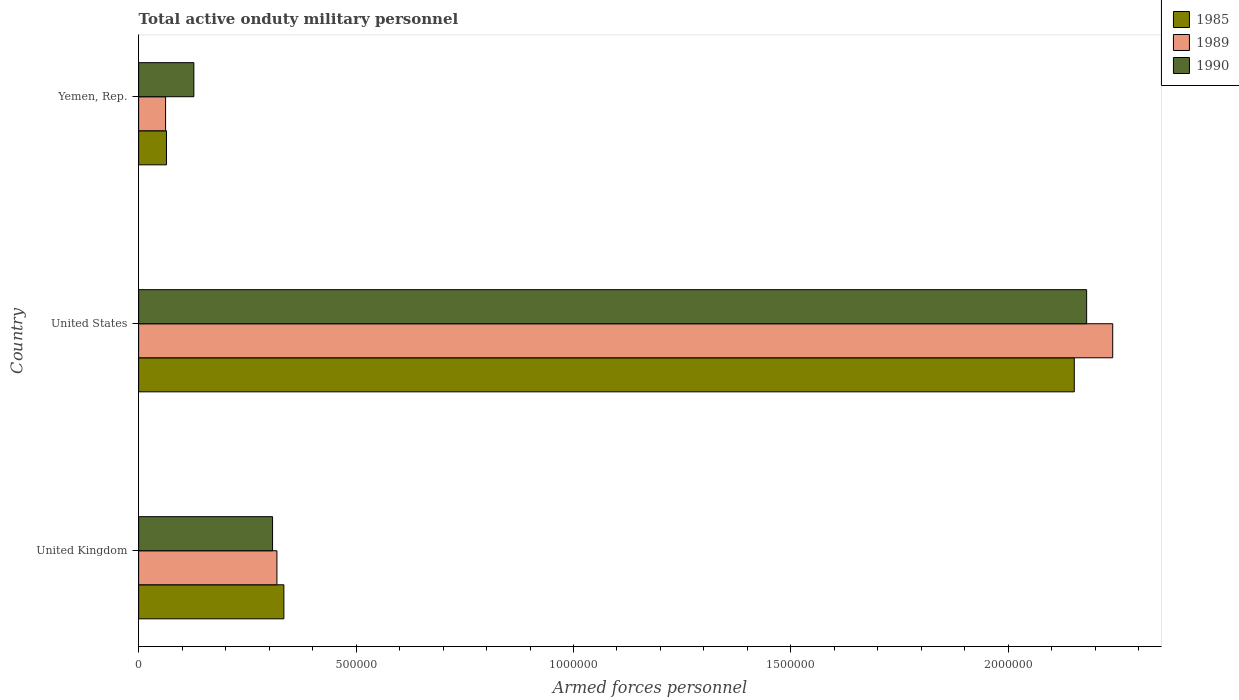Are the number of bars per tick equal to the number of legend labels?
Give a very brief answer. Yes. How many bars are there on the 3rd tick from the top?
Make the answer very short. 3. What is the number of armed forces personnel in 1985 in United Kingdom?
Give a very brief answer. 3.34e+05. Across all countries, what is the maximum number of armed forces personnel in 1985?
Provide a succinct answer. 2.15e+06. Across all countries, what is the minimum number of armed forces personnel in 1985?
Make the answer very short. 6.41e+04. In which country was the number of armed forces personnel in 1985 minimum?
Your response must be concise. Yemen, Rep. What is the total number of armed forces personnel in 1990 in the graph?
Your response must be concise. 2.62e+06. What is the difference between the number of armed forces personnel in 1985 in United Kingdom and that in Yemen, Rep.?
Provide a short and direct response. 2.70e+05. What is the difference between the number of armed forces personnel in 1989 in Yemen, Rep. and the number of armed forces personnel in 1990 in United States?
Offer a terse response. -2.12e+06. What is the average number of armed forces personnel in 1985 per country?
Provide a short and direct response. 8.50e+05. What is the difference between the number of armed forces personnel in 1990 and number of armed forces personnel in 1985 in United Kingdom?
Keep it short and to the point. -2.60e+04. In how many countries, is the number of armed forces personnel in 1990 greater than 1700000 ?
Provide a succinct answer. 1. What is the ratio of the number of armed forces personnel in 1985 in United States to that in Yemen, Rep.?
Offer a very short reply. 33.57. Is the difference between the number of armed forces personnel in 1990 in United Kingdom and Yemen, Rep. greater than the difference between the number of armed forces personnel in 1985 in United Kingdom and Yemen, Rep.?
Your answer should be very brief. No. What is the difference between the highest and the second highest number of armed forces personnel in 1989?
Make the answer very short. 1.92e+06. What is the difference between the highest and the lowest number of armed forces personnel in 1990?
Provide a succinct answer. 2.05e+06. In how many countries, is the number of armed forces personnel in 1990 greater than the average number of armed forces personnel in 1990 taken over all countries?
Provide a short and direct response. 1. What does the 2nd bar from the bottom in United Kingdom represents?
Offer a terse response. 1989. Is it the case that in every country, the sum of the number of armed forces personnel in 1985 and number of armed forces personnel in 1990 is greater than the number of armed forces personnel in 1989?
Offer a very short reply. Yes. Are all the bars in the graph horizontal?
Your response must be concise. Yes. How many countries are there in the graph?
Keep it short and to the point. 3. What is the difference between two consecutive major ticks on the X-axis?
Offer a very short reply. 5.00e+05. Are the values on the major ticks of X-axis written in scientific E-notation?
Offer a terse response. No. Where does the legend appear in the graph?
Ensure brevity in your answer.  Top right. What is the title of the graph?
Make the answer very short. Total active onduty military personnel. What is the label or title of the X-axis?
Provide a short and direct response. Armed forces personnel. What is the Armed forces personnel of 1985 in United Kingdom?
Provide a succinct answer. 3.34e+05. What is the Armed forces personnel of 1989 in United Kingdom?
Make the answer very short. 3.18e+05. What is the Armed forces personnel in 1990 in United Kingdom?
Provide a succinct answer. 3.08e+05. What is the Armed forces personnel of 1985 in United States?
Give a very brief answer. 2.15e+06. What is the Armed forces personnel of 1989 in United States?
Your response must be concise. 2.24e+06. What is the Armed forces personnel of 1990 in United States?
Provide a short and direct response. 2.18e+06. What is the Armed forces personnel in 1985 in Yemen, Rep.?
Provide a short and direct response. 6.41e+04. What is the Armed forces personnel of 1989 in Yemen, Rep.?
Your answer should be very brief. 6.20e+04. What is the Armed forces personnel of 1990 in Yemen, Rep.?
Provide a short and direct response. 1.27e+05. Across all countries, what is the maximum Armed forces personnel of 1985?
Your answer should be compact. 2.15e+06. Across all countries, what is the maximum Armed forces personnel in 1989?
Offer a terse response. 2.24e+06. Across all countries, what is the maximum Armed forces personnel in 1990?
Your response must be concise. 2.18e+06. Across all countries, what is the minimum Armed forces personnel of 1985?
Ensure brevity in your answer.  6.41e+04. Across all countries, what is the minimum Armed forces personnel in 1989?
Make the answer very short. 6.20e+04. Across all countries, what is the minimum Armed forces personnel in 1990?
Ensure brevity in your answer.  1.27e+05. What is the total Armed forces personnel in 1985 in the graph?
Your response must be concise. 2.55e+06. What is the total Armed forces personnel in 1989 in the graph?
Make the answer very short. 2.62e+06. What is the total Armed forces personnel in 1990 in the graph?
Ensure brevity in your answer.  2.62e+06. What is the difference between the Armed forces personnel of 1985 in United Kingdom and that in United States?
Your answer should be compact. -1.82e+06. What is the difference between the Armed forces personnel of 1989 in United Kingdom and that in United States?
Make the answer very short. -1.92e+06. What is the difference between the Armed forces personnel in 1990 in United Kingdom and that in United States?
Provide a succinct answer. -1.87e+06. What is the difference between the Armed forces personnel in 1985 in United Kingdom and that in Yemen, Rep.?
Your answer should be very brief. 2.70e+05. What is the difference between the Armed forces personnel of 1989 in United Kingdom and that in Yemen, Rep.?
Your answer should be compact. 2.56e+05. What is the difference between the Armed forces personnel of 1990 in United Kingdom and that in Yemen, Rep.?
Provide a succinct answer. 1.81e+05. What is the difference between the Armed forces personnel of 1985 in United States and that in Yemen, Rep.?
Provide a short and direct response. 2.09e+06. What is the difference between the Armed forces personnel of 1989 in United States and that in Yemen, Rep.?
Your response must be concise. 2.18e+06. What is the difference between the Armed forces personnel in 1990 in United States and that in Yemen, Rep.?
Offer a very short reply. 2.05e+06. What is the difference between the Armed forces personnel in 1985 in United Kingdom and the Armed forces personnel in 1989 in United States?
Your response must be concise. -1.91e+06. What is the difference between the Armed forces personnel of 1985 in United Kingdom and the Armed forces personnel of 1990 in United States?
Your answer should be very brief. -1.85e+06. What is the difference between the Armed forces personnel of 1989 in United Kingdom and the Armed forces personnel of 1990 in United States?
Ensure brevity in your answer.  -1.86e+06. What is the difference between the Armed forces personnel of 1985 in United Kingdom and the Armed forces personnel of 1989 in Yemen, Rep.?
Your answer should be compact. 2.72e+05. What is the difference between the Armed forces personnel in 1985 in United Kingdom and the Armed forces personnel in 1990 in Yemen, Rep.?
Ensure brevity in your answer.  2.07e+05. What is the difference between the Armed forces personnel in 1989 in United Kingdom and the Armed forces personnel in 1990 in Yemen, Rep.?
Provide a short and direct response. 1.91e+05. What is the difference between the Armed forces personnel of 1985 in United States and the Armed forces personnel of 1989 in Yemen, Rep.?
Your answer should be compact. 2.09e+06. What is the difference between the Armed forces personnel in 1985 in United States and the Armed forces personnel in 1990 in Yemen, Rep.?
Keep it short and to the point. 2.02e+06. What is the difference between the Armed forces personnel of 1989 in United States and the Armed forces personnel of 1990 in Yemen, Rep.?
Keep it short and to the point. 2.11e+06. What is the average Armed forces personnel of 1985 per country?
Make the answer very short. 8.50e+05. What is the average Armed forces personnel of 1989 per country?
Provide a succinct answer. 8.73e+05. What is the average Armed forces personnel in 1990 per country?
Offer a terse response. 8.72e+05. What is the difference between the Armed forces personnel of 1985 and Armed forces personnel of 1989 in United Kingdom?
Your response must be concise. 1.60e+04. What is the difference between the Armed forces personnel of 1985 and Armed forces personnel of 1990 in United Kingdom?
Provide a short and direct response. 2.60e+04. What is the difference between the Armed forces personnel in 1989 and Armed forces personnel in 1990 in United Kingdom?
Your answer should be compact. 10000. What is the difference between the Armed forces personnel in 1985 and Armed forces personnel in 1989 in United States?
Offer a very short reply. -8.84e+04. What is the difference between the Armed forces personnel of 1985 and Armed forces personnel of 1990 in United States?
Your answer should be very brief. -2.84e+04. What is the difference between the Armed forces personnel in 1989 and Armed forces personnel in 1990 in United States?
Offer a terse response. 6.00e+04. What is the difference between the Armed forces personnel of 1985 and Armed forces personnel of 1989 in Yemen, Rep.?
Keep it short and to the point. 2100. What is the difference between the Armed forces personnel of 1985 and Armed forces personnel of 1990 in Yemen, Rep.?
Ensure brevity in your answer.  -6.29e+04. What is the difference between the Armed forces personnel in 1989 and Armed forces personnel in 1990 in Yemen, Rep.?
Your answer should be very brief. -6.50e+04. What is the ratio of the Armed forces personnel in 1985 in United Kingdom to that in United States?
Provide a short and direct response. 0.16. What is the ratio of the Armed forces personnel in 1989 in United Kingdom to that in United States?
Your answer should be compact. 0.14. What is the ratio of the Armed forces personnel of 1990 in United Kingdom to that in United States?
Make the answer very short. 0.14. What is the ratio of the Armed forces personnel in 1985 in United Kingdom to that in Yemen, Rep.?
Give a very brief answer. 5.21. What is the ratio of the Armed forces personnel in 1989 in United Kingdom to that in Yemen, Rep.?
Offer a very short reply. 5.13. What is the ratio of the Armed forces personnel in 1990 in United Kingdom to that in Yemen, Rep.?
Your answer should be very brief. 2.43. What is the ratio of the Armed forces personnel in 1985 in United States to that in Yemen, Rep.?
Your response must be concise. 33.57. What is the ratio of the Armed forces personnel in 1989 in United States to that in Yemen, Rep.?
Keep it short and to the point. 36.13. What is the ratio of the Armed forces personnel in 1990 in United States to that in Yemen, Rep.?
Ensure brevity in your answer.  17.17. What is the difference between the highest and the second highest Armed forces personnel of 1985?
Make the answer very short. 1.82e+06. What is the difference between the highest and the second highest Armed forces personnel in 1989?
Your response must be concise. 1.92e+06. What is the difference between the highest and the second highest Armed forces personnel of 1990?
Offer a terse response. 1.87e+06. What is the difference between the highest and the lowest Armed forces personnel in 1985?
Your answer should be very brief. 2.09e+06. What is the difference between the highest and the lowest Armed forces personnel in 1989?
Your response must be concise. 2.18e+06. What is the difference between the highest and the lowest Armed forces personnel in 1990?
Your answer should be compact. 2.05e+06. 